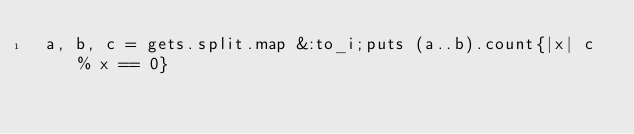<code> <loc_0><loc_0><loc_500><loc_500><_Ruby_> a, b, c = gets.split.map &:to_i;puts (a..b).count{|x| c % x == 0}
</code> 